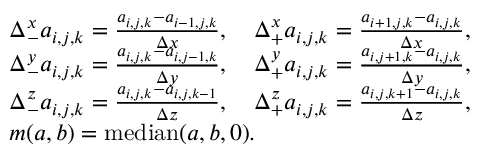Convert formula to latex. <formula><loc_0><loc_0><loc_500><loc_500>\begin{array} { r l } & { \Delta _ { - } ^ { x } a _ { i , j , k } = \frac { a _ { i , j , k } - a _ { i - 1 , j , k } } { \Delta x } , \quad \Delta _ { + } ^ { x } a _ { i , j , k } = \frac { a _ { i + 1 , j , k } - a _ { i , j , k } } { \Delta x } , } \\ & { \Delta _ { - } ^ { y } a _ { i , j , k } = \frac { a _ { i , j , k } - a _ { i , j - 1 , k } } { \Delta y } , \quad \Delta _ { + } ^ { y } a _ { i , j , k } = \frac { a _ { i , j + 1 , k } - a _ { i , j , k } } { \Delta y } , } \\ & { \Delta _ { - } ^ { z } a _ { i , j , k } = \frac { a _ { i , j , k } - a _ { i , j , k - 1 } } { \Delta z } , \quad \Delta _ { + } ^ { z } a _ { i , j , k } = \frac { a _ { i , j , k + 1 } - a _ { i , j , k } } { \Delta z } , } \\ & { m ( a , b ) = m e d i a n ( a , b , 0 ) . } \end{array}</formula> 